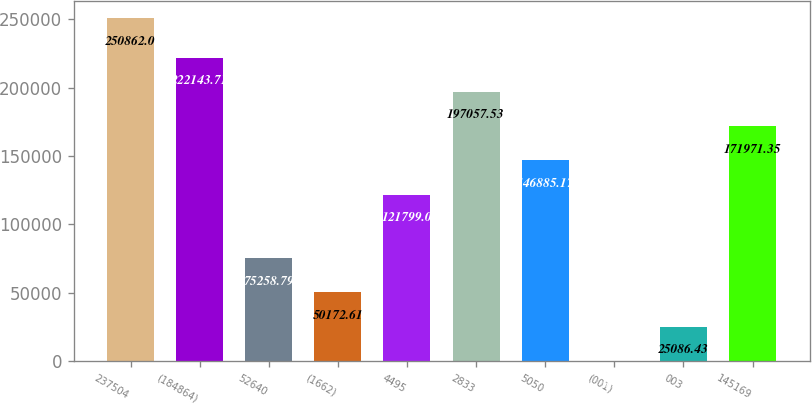Convert chart. <chart><loc_0><loc_0><loc_500><loc_500><bar_chart><fcel>237504<fcel>(184864)<fcel>52640<fcel>(1662)<fcel>4495<fcel>2833<fcel>5050<fcel>(001)<fcel>003<fcel>145169<nl><fcel>250862<fcel>222144<fcel>75258.8<fcel>50172.6<fcel>121799<fcel>197058<fcel>146885<fcel>0.25<fcel>25086.4<fcel>171971<nl></chart> 